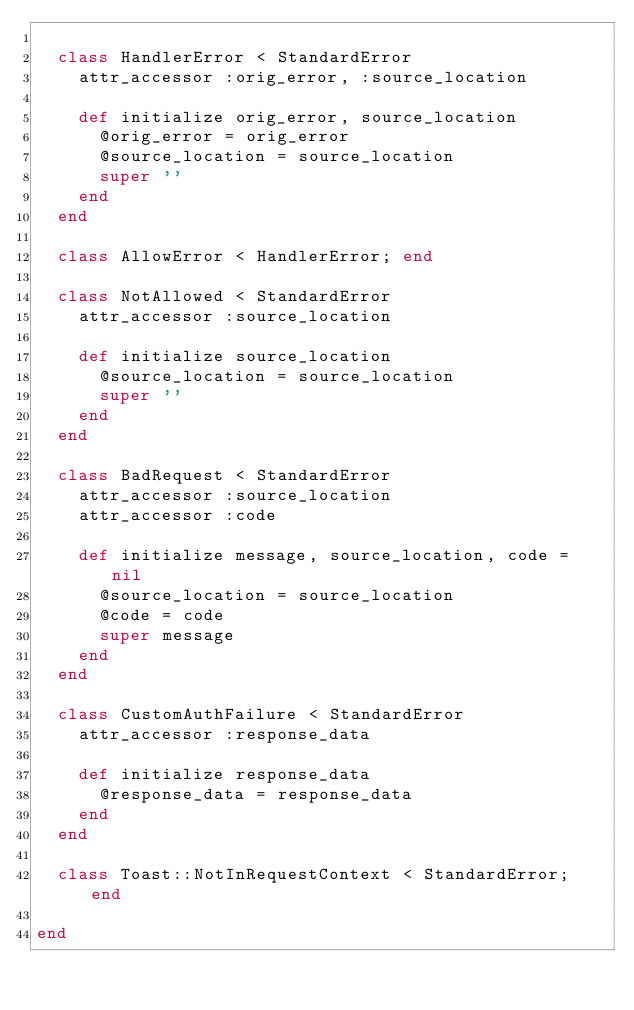Convert code to text. <code><loc_0><loc_0><loc_500><loc_500><_Ruby_>
  class HandlerError < StandardError
    attr_accessor :orig_error, :source_location

    def initialize orig_error, source_location
      @orig_error = orig_error
      @source_location = source_location
      super ''
    end
  end

  class AllowError < HandlerError; end

  class NotAllowed < StandardError
    attr_accessor :source_location

    def initialize source_location
      @source_location = source_location
      super ''
    end
  end

  class BadRequest < StandardError
    attr_accessor :source_location
    attr_accessor :code

    def initialize message, source_location, code = nil
      @source_location = source_location
      @code = code
      super message
    end
  end

  class CustomAuthFailure < StandardError
    attr_accessor :response_data

    def initialize response_data
      @response_data = response_data
    end
  end

  class Toast::NotInRequestContext < StandardError; end

end
</code> 